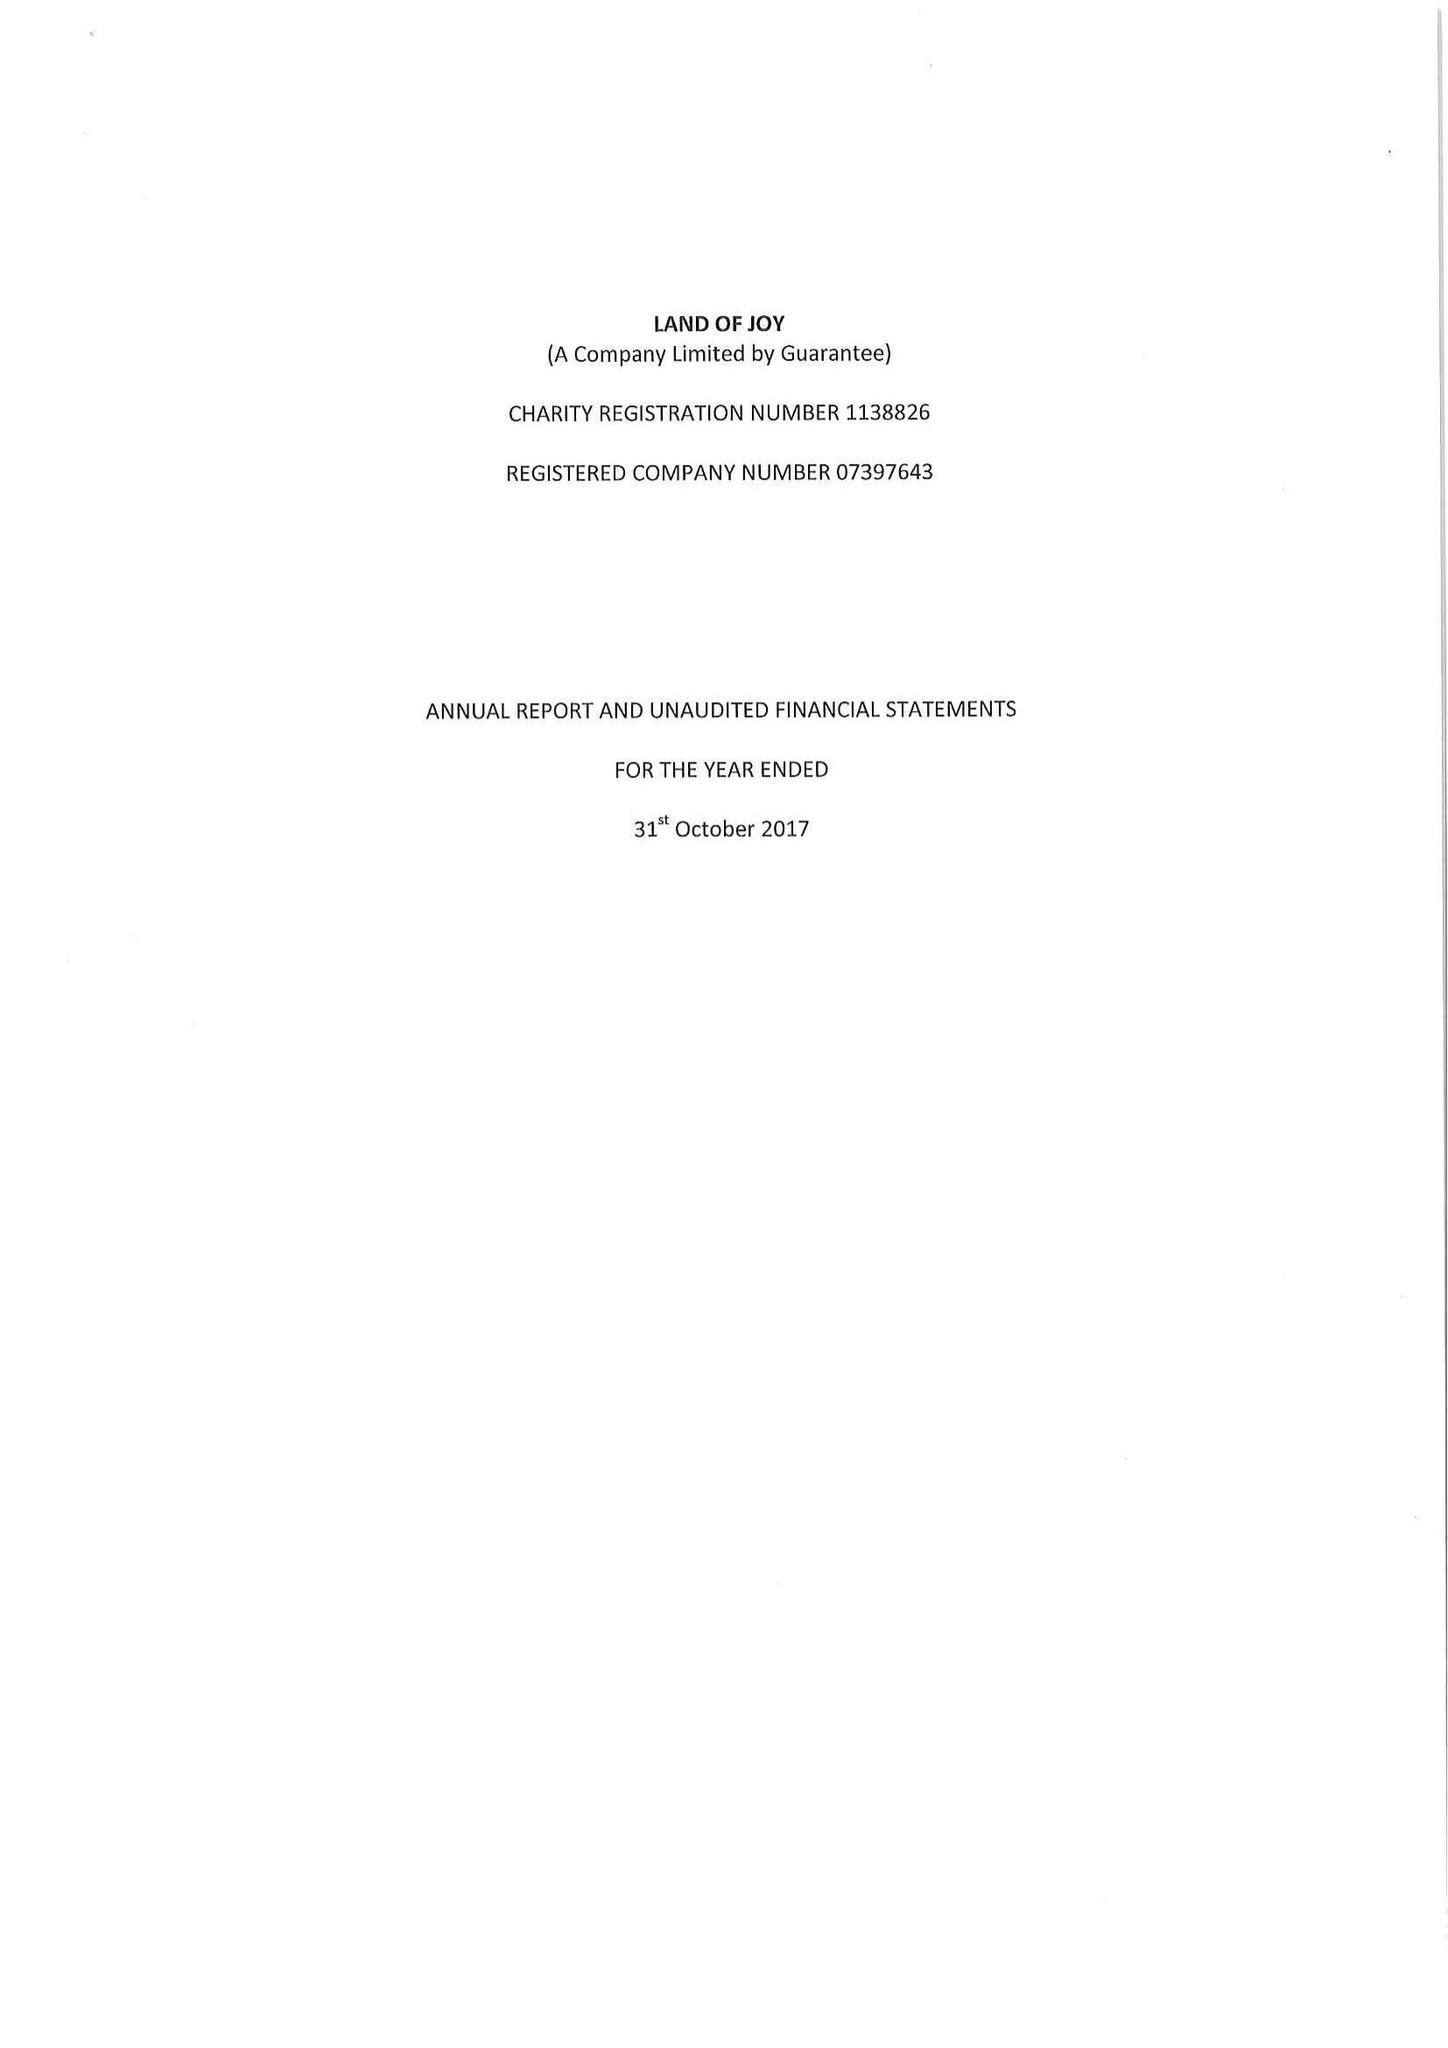What is the value for the address__postcode?
Answer the question using a single word or phrase. NE48 1PP 